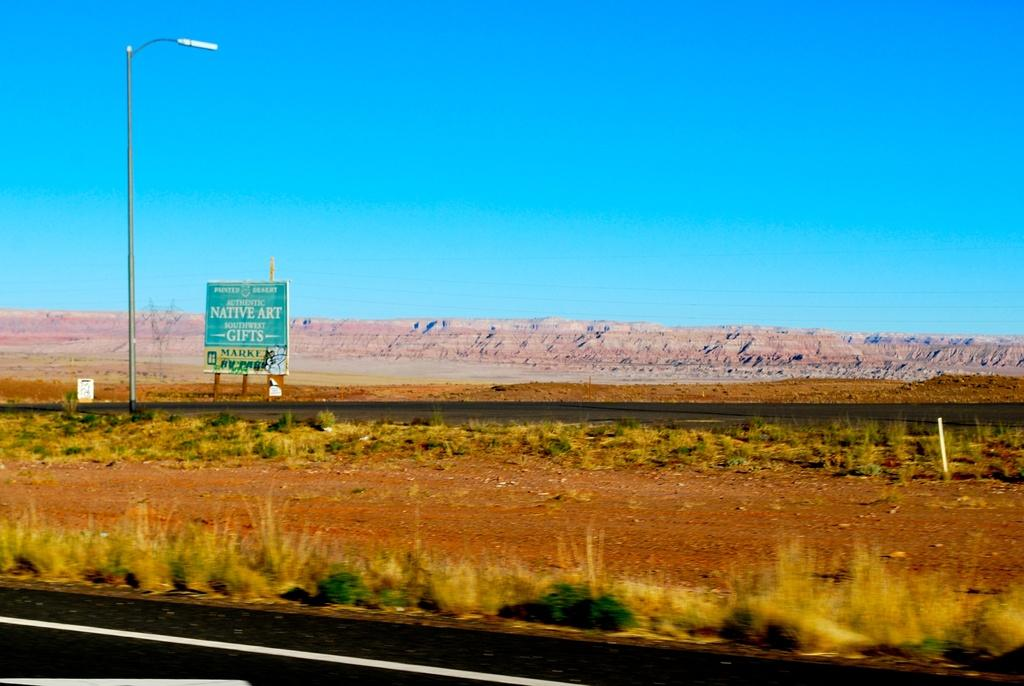What type of vegetation is in the center of the image? There is dry grass in the center of the image. What else can be seen in the image besides the dry grass? There are plants in the image. What is located in the background of the image? There is a board with text and a pole in the background of the image. What type of surface is visible in the image? There is land visible in the image. What word is written on the zebra in the image? There is no zebra present in the image, and therefore no word can be written on it. 